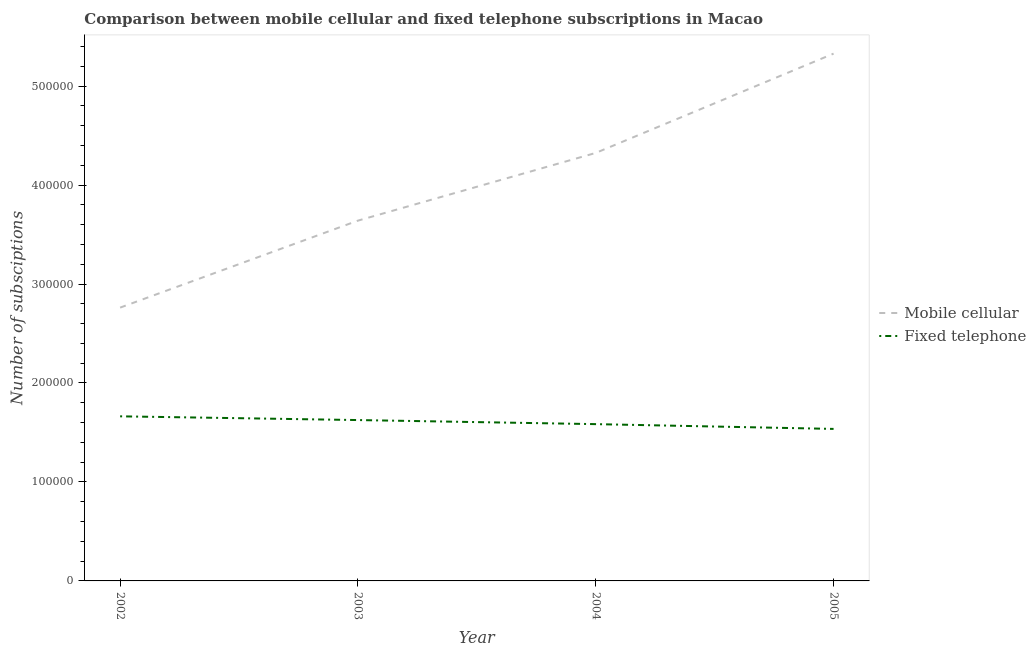Does the line corresponding to number of fixed telephone subscriptions intersect with the line corresponding to number of mobile cellular subscriptions?
Ensure brevity in your answer.  No. Is the number of lines equal to the number of legend labels?
Give a very brief answer. Yes. What is the number of mobile cellular subscriptions in 2004?
Make the answer very short. 4.32e+05. Across all years, what is the maximum number of fixed telephone subscriptions?
Your answer should be very brief. 1.66e+05. Across all years, what is the minimum number of fixed telephone subscriptions?
Offer a terse response. 1.54e+05. In which year was the number of mobile cellular subscriptions maximum?
Offer a very short reply. 2005. In which year was the number of fixed telephone subscriptions minimum?
Offer a very short reply. 2005. What is the total number of fixed telephone subscriptions in the graph?
Your response must be concise. 6.41e+05. What is the difference between the number of mobile cellular subscriptions in 2003 and that in 2004?
Your response must be concise. -6.84e+04. What is the difference between the number of fixed telephone subscriptions in 2002 and the number of mobile cellular subscriptions in 2005?
Provide a succinct answer. -3.66e+05. What is the average number of fixed telephone subscriptions per year?
Give a very brief answer. 1.60e+05. In the year 2002, what is the difference between the number of fixed telephone subscriptions and number of mobile cellular subscriptions?
Give a very brief answer. -1.10e+05. What is the ratio of the number of mobile cellular subscriptions in 2002 to that in 2003?
Ensure brevity in your answer.  0.76. Is the number of mobile cellular subscriptions in 2003 less than that in 2004?
Keep it short and to the point. Yes. Is the difference between the number of fixed telephone subscriptions in 2002 and 2004 greater than the difference between the number of mobile cellular subscriptions in 2002 and 2004?
Ensure brevity in your answer.  Yes. What is the difference between the highest and the second highest number of fixed telephone subscriptions?
Offer a terse response. 3777. What is the difference between the highest and the lowest number of mobile cellular subscriptions?
Ensure brevity in your answer.  2.57e+05. In how many years, is the number of mobile cellular subscriptions greater than the average number of mobile cellular subscriptions taken over all years?
Ensure brevity in your answer.  2. Is the number of fixed telephone subscriptions strictly greater than the number of mobile cellular subscriptions over the years?
Provide a succinct answer. No. Is the number of fixed telephone subscriptions strictly less than the number of mobile cellular subscriptions over the years?
Offer a terse response. Yes. How many lines are there?
Your answer should be compact. 2. How many years are there in the graph?
Provide a succinct answer. 4. Are the values on the major ticks of Y-axis written in scientific E-notation?
Give a very brief answer. No. Does the graph contain any zero values?
Offer a very short reply. No. Does the graph contain grids?
Your response must be concise. No. Where does the legend appear in the graph?
Offer a very short reply. Center right. How many legend labels are there?
Keep it short and to the point. 2. What is the title of the graph?
Give a very brief answer. Comparison between mobile cellular and fixed telephone subscriptions in Macao. What is the label or title of the Y-axis?
Make the answer very short. Number of subsciptions. What is the Number of subsciptions of Mobile cellular in 2002?
Offer a terse response. 2.76e+05. What is the Number of subsciptions of Fixed telephone in 2002?
Provide a short and direct response. 1.66e+05. What is the Number of subsciptions in Mobile cellular in 2003?
Offer a very short reply. 3.64e+05. What is the Number of subsciptions of Fixed telephone in 2003?
Your answer should be compact. 1.63e+05. What is the Number of subsciptions in Mobile cellular in 2004?
Offer a terse response. 4.32e+05. What is the Number of subsciptions of Fixed telephone in 2004?
Offer a terse response. 1.58e+05. What is the Number of subsciptions of Mobile cellular in 2005?
Make the answer very short. 5.33e+05. What is the Number of subsciptions of Fixed telephone in 2005?
Your response must be concise. 1.54e+05. Across all years, what is the maximum Number of subsciptions of Mobile cellular?
Give a very brief answer. 5.33e+05. Across all years, what is the maximum Number of subsciptions in Fixed telephone?
Offer a very short reply. 1.66e+05. Across all years, what is the minimum Number of subsciptions of Mobile cellular?
Offer a terse response. 2.76e+05. Across all years, what is the minimum Number of subsciptions in Fixed telephone?
Provide a short and direct response. 1.54e+05. What is the total Number of subsciptions of Mobile cellular in the graph?
Your answer should be compact. 1.61e+06. What is the total Number of subsciptions in Fixed telephone in the graph?
Offer a terse response. 6.41e+05. What is the difference between the Number of subsciptions of Mobile cellular in 2002 and that in 2003?
Provide a short and direct response. -8.79e+04. What is the difference between the Number of subsciptions of Fixed telephone in 2002 and that in 2003?
Your response must be concise. 3777. What is the difference between the Number of subsciptions of Mobile cellular in 2002 and that in 2004?
Offer a very short reply. -1.56e+05. What is the difference between the Number of subsciptions in Fixed telephone in 2002 and that in 2004?
Give a very brief answer. 7896. What is the difference between the Number of subsciptions of Mobile cellular in 2002 and that in 2005?
Your answer should be very brief. -2.57e+05. What is the difference between the Number of subsciptions of Fixed telephone in 2002 and that in 2005?
Your response must be concise. 1.27e+04. What is the difference between the Number of subsciptions of Mobile cellular in 2003 and that in 2004?
Provide a short and direct response. -6.84e+04. What is the difference between the Number of subsciptions in Fixed telephone in 2003 and that in 2004?
Offer a terse response. 4119. What is the difference between the Number of subsciptions in Mobile cellular in 2003 and that in 2005?
Keep it short and to the point. -1.69e+05. What is the difference between the Number of subsciptions in Fixed telephone in 2003 and that in 2005?
Make the answer very short. 8946. What is the difference between the Number of subsciptions of Mobile cellular in 2004 and that in 2005?
Ensure brevity in your answer.  -1.00e+05. What is the difference between the Number of subsciptions in Fixed telephone in 2004 and that in 2005?
Ensure brevity in your answer.  4827. What is the difference between the Number of subsciptions in Mobile cellular in 2002 and the Number of subsciptions in Fixed telephone in 2003?
Your answer should be compact. 1.14e+05. What is the difference between the Number of subsciptions in Mobile cellular in 2002 and the Number of subsciptions in Fixed telephone in 2004?
Provide a short and direct response. 1.18e+05. What is the difference between the Number of subsciptions of Mobile cellular in 2002 and the Number of subsciptions of Fixed telephone in 2005?
Provide a succinct answer. 1.23e+05. What is the difference between the Number of subsciptions in Mobile cellular in 2003 and the Number of subsciptions in Fixed telephone in 2004?
Provide a short and direct response. 2.06e+05. What is the difference between the Number of subsciptions of Mobile cellular in 2003 and the Number of subsciptions of Fixed telephone in 2005?
Your response must be concise. 2.10e+05. What is the difference between the Number of subsciptions in Mobile cellular in 2004 and the Number of subsciptions in Fixed telephone in 2005?
Offer a very short reply. 2.79e+05. What is the average Number of subsciptions of Mobile cellular per year?
Provide a short and direct response. 4.01e+05. What is the average Number of subsciptions of Fixed telephone per year?
Offer a very short reply. 1.60e+05. In the year 2002, what is the difference between the Number of subsciptions in Mobile cellular and Number of subsciptions in Fixed telephone?
Keep it short and to the point. 1.10e+05. In the year 2003, what is the difference between the Number of subsciptions of Mobile cellular and Number of subsciptions of Fixed telephone?
Keep it short and to the point. 2.01e+05. In the year 2004, what is the difference between the Number of subsciptions of Mobile cellular and Number of subsciptions of Fixed telephone?
Ensure brevity in your answer.  2.74e+05. In the year 2005, what is the difference between the Number of subsciptions of Mobile cellular and Number of subsciptions of Fixed telephone?
Your answer should be compact. 3.79e+05. What is the ratio of the Number of subsciptions of Mobile cellular in 2002 to that in 2003?
Give a very brief answer. 0.76. What is the ratio of the Number of subsciptions of Fixed telephone in 2002 to that in 2003?
Your answer should be very brief. 1.02. What is the ratio of the Number of subsciptions of Mobile cellular in 2002 to that in 2004?
Your answer should be very brief. 0.64. What is the ratio of the Number of subsciptions in Fixed telephone in 2002 to that in 2004?
Your answer should be very brief. 1.05. What is the ratio of the Number of subsciptions in Mobile cellular in 2002 to that in 2005?
Keep it short and to the point. 0.52. What is the ratio of the Number of subsciptions in Fixed telephone in 2002 to that in 2005?
Offer a terse response. 1.08. What is the ratio of the Number of subsciptions of Mobile cellular in 2003 to that in 2004?
Your answer should be compact. 0.84. What is the ratio of the Number of subsciptions in Fixed telephone in 2003 to that in 2004?
Keep it short and to the point. 1.03. What is the ratio of the Number of subsciptions in Mobile cellular in 2003 to that in 2005?
Ensure brevity in your answer.  0.68. What is the ratio of the Number of subsciptions of Fixed telephone in 2003 to that in 2005?
Give a very brief answer. 1.06. What is the ratio of the Number of subsciptions in Mobile cellular in 2004 to that in 2005?
Keep it short and to the point. 0.81. What is the ratio of the Number of subsciptions in Fixed telephone in 2004 to that in 2005?
Provide a succinct answer. 1.03. What is the difference between the highest and the second highest Number of subsciptions of Mobile cellular?
Offer a terse response. 1.00e+05. What is the difference between the highest and the second highest Number of subsciptions in Fixed telephone?
Make the answer very short. 3777. What is the difference between the highest and the lowest Number of subsciptions in Mobile cellular?
Provide a succinct answer. 2.57e+05. What is the difference between the highest and the lowest Number of subsciptions of Fixed telephone?
Keep it short and to the point. 1.27e+04. 